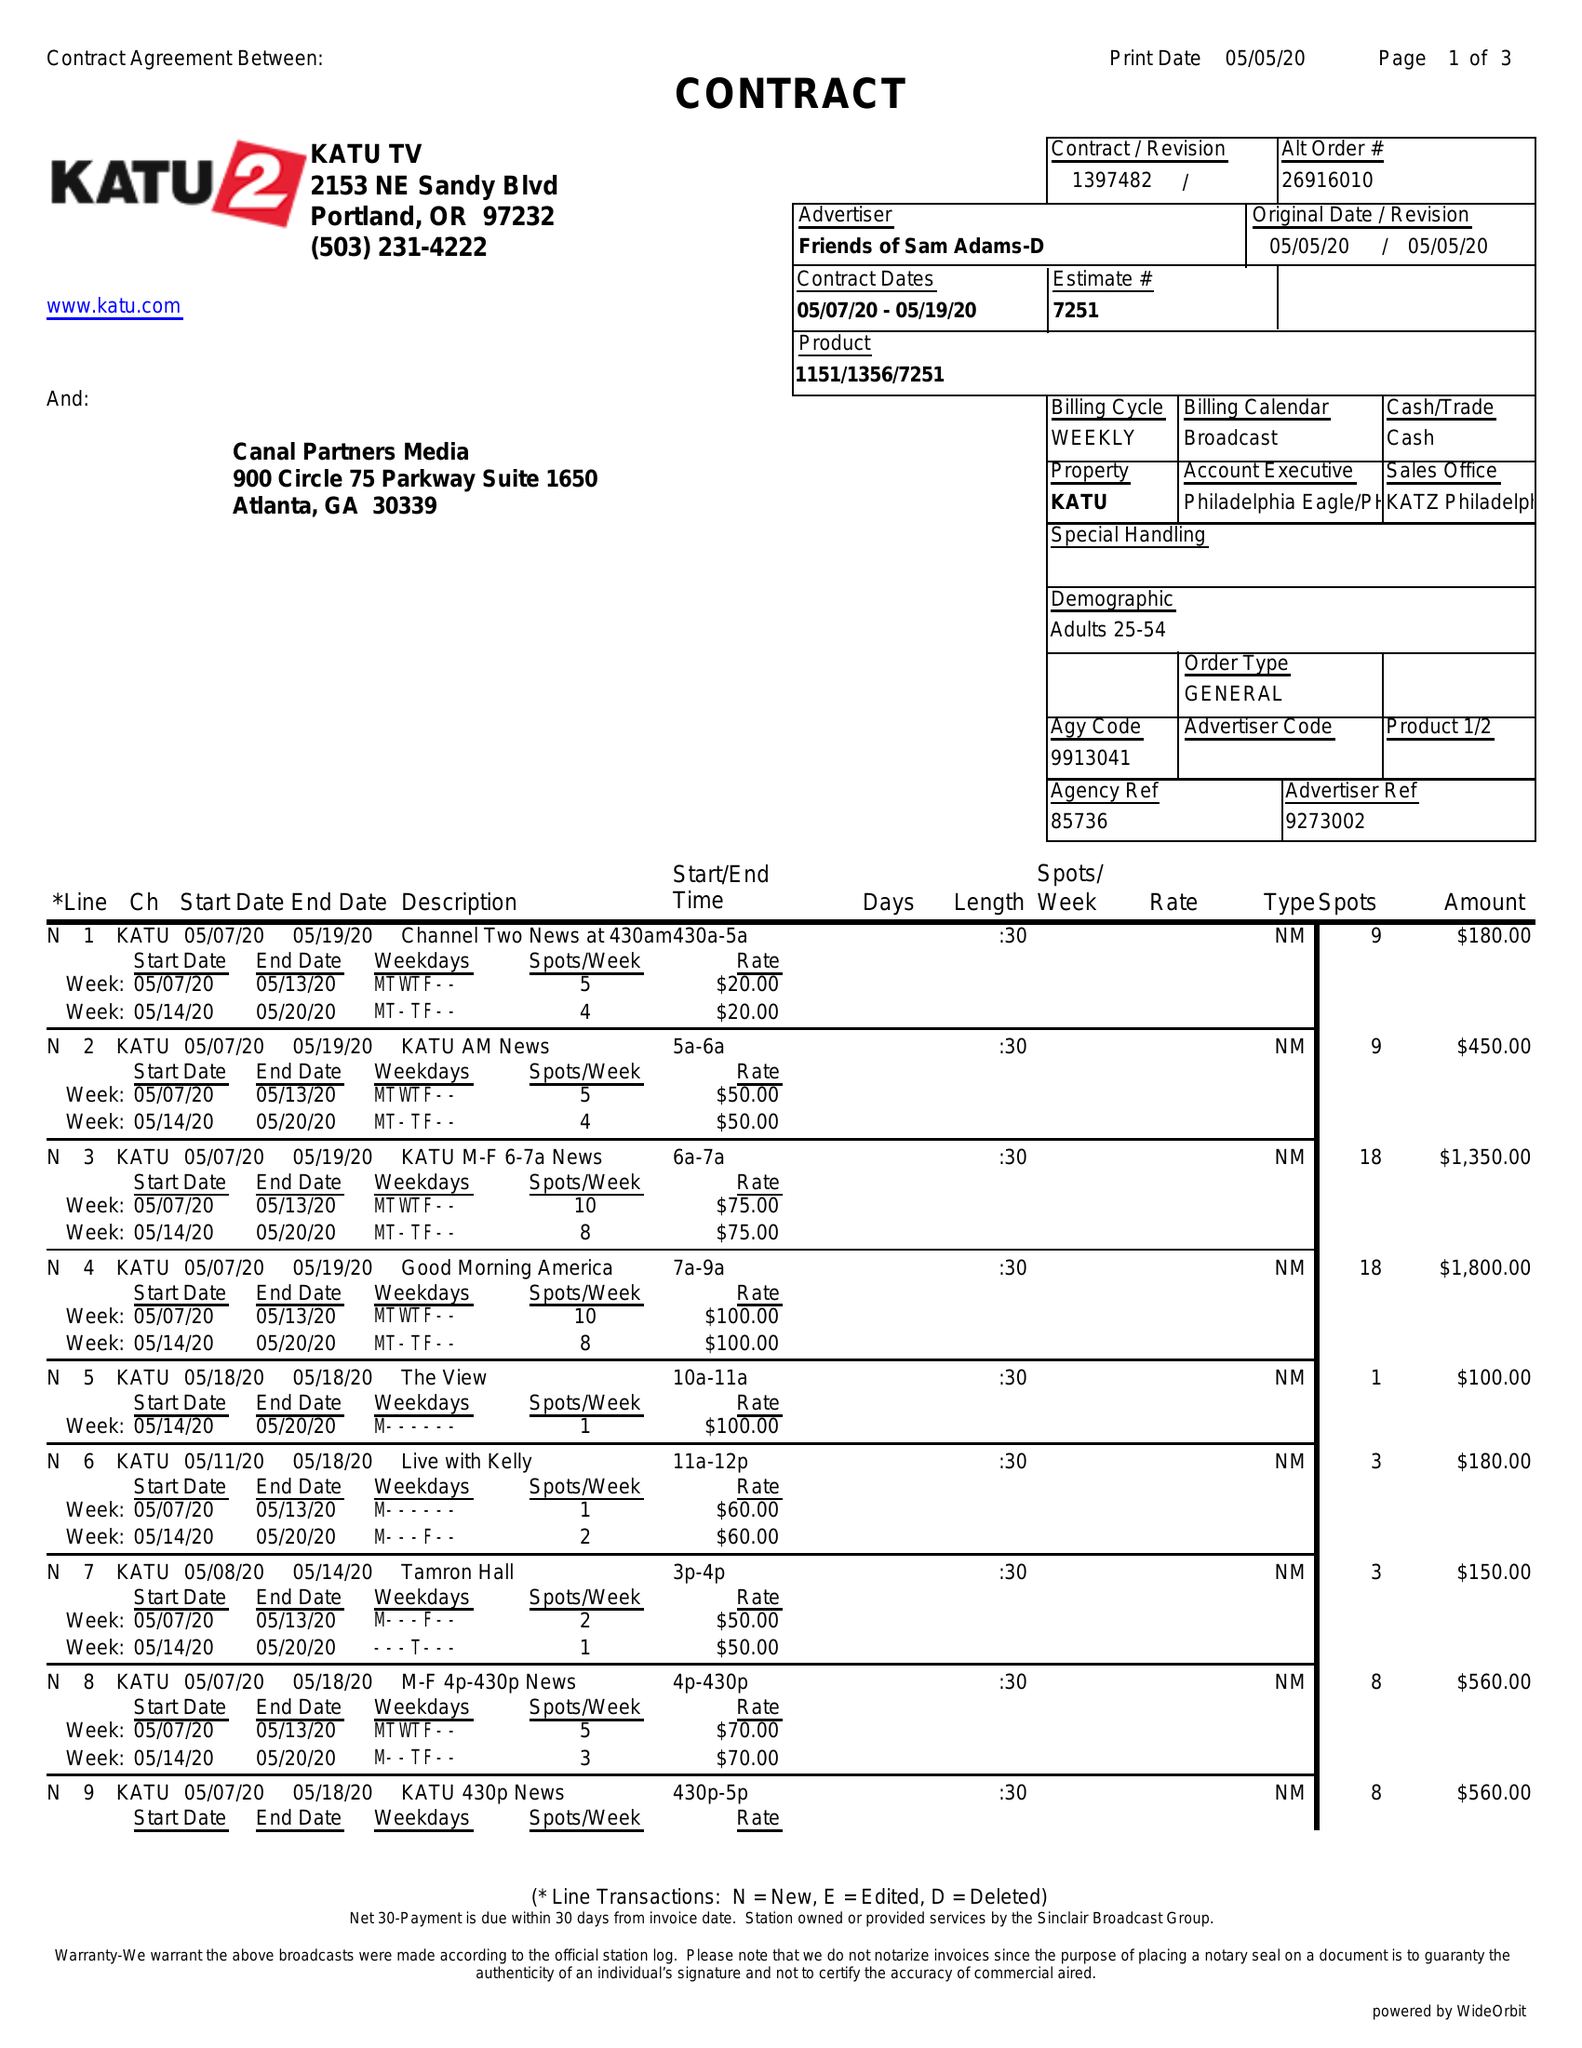What is the value for the contract_num?
Answer the question using a single word or phrase. 1397482 